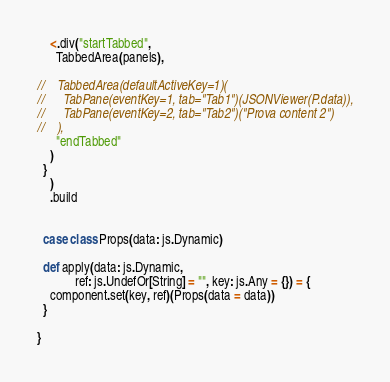Convert code to text. <code><loc_0><loc_0><loc_500><loc_500><_Scala_>

    <.div("startTabbed",
      TabbedArea(panels),

//    TabbedArea(defaultActiveKey=1)(
//      TabPane(eventKey=1, tab="Tab1")(JSONViewer(P.data)),
//      TabPane(eventKey=2, tab="Tab2")("Prova content 2")
//    ),
      "endTabbed"
    )
  }
    )
    .build


  case class Props(data: js.Dynamic)

  def apply(data: js.Dynamic,
            ref: js.UndefOr[String] = "", key: js.Any = {}) = {
    component.set(key, ref)(Props(data = data))
  }

}
</code> 